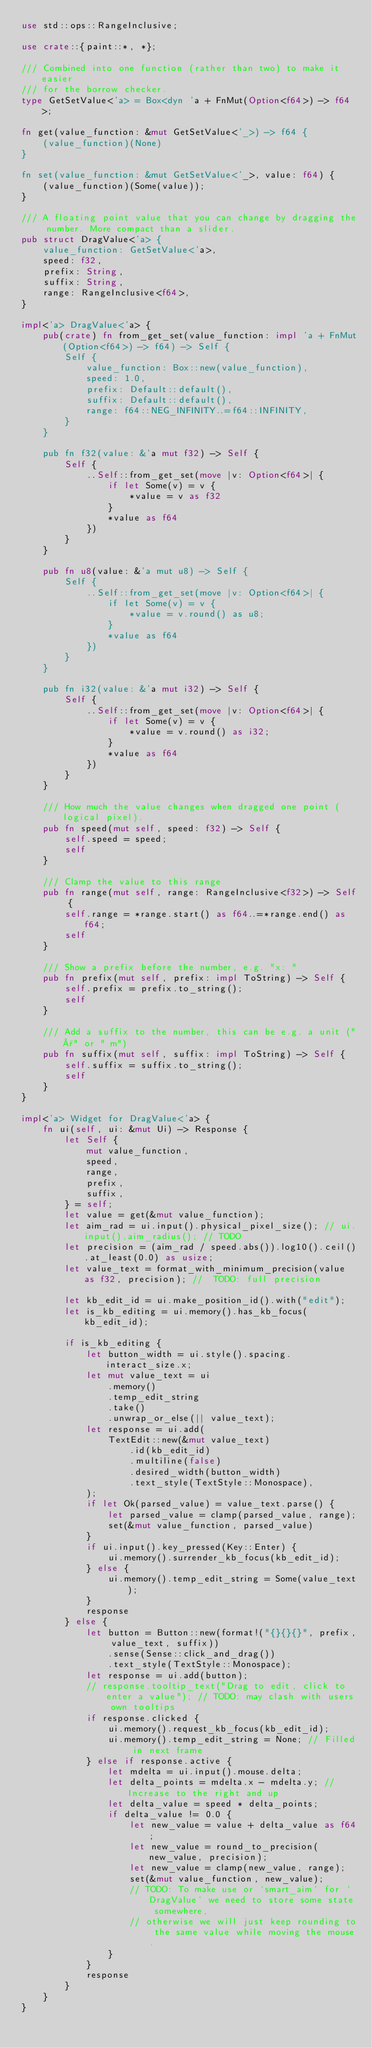<code> <loc_0><loc_0><loc_500><loc_500><_Rust_>use std::ops::RangeInclusive;

use crate::{paint::*, *};

/// Combined into one function (rather than two) to make it easier
/// for the borrow checker.
type GetSetValue<'a> = Box<dyn 'a + FnMut(Option<f64>) -> f64>;

fn get(value_function: &mut GetSetValue<'_>) -> f64 {
    (value_function)(None)
}

fn set(value_function: &mut GetSetValue<'_>, value: f64) {
    (value_function)(Some(value));
}

/// A floating point value that you can change by dragging the number. More compact than a slider.
pub struct DragValue<'a> {
    value_function: GetSetValue<'a>,
    speed: f32,
    prefix: String,
    suffix: String,
    range: RangeInclusive<f64>,
}

impl<'a> DragValue<'a> {
    pub(crate) fn from_get_set(value_function: impl 'a + FnMut(Option<f64>) -> f64) -> Self {
        Self {
            value_function: Box::new(value_function),
            speed: 1.0,
            prefix: Default::default(),
            suffix: Default::default(),
            range: f64::NEG_INFINITY..=f64::INFINITY,
        }
    }

    pub fn f32(value: &'a mut f32) -> Self {
        Self {
            ..Self::from_get_set(move |v: Option<f64>| {
                if let Some(v) = v {
                    *value = v as f32
                }
                *value as f64
            })
        }
    }

    pub fn u8(value: &'a mut u8) -> Self {
        Self {
            ..Self::from_get_set(move |v: Option<f64>| {
                if let Some(v) = v {
                    *value = v.round() as u8;
                }
                *value as f64
            })
        }
    }

    pub fn i32(value: &'a mut i32) -> Self {
        Self {
            ..Self::from_get_set(move |v: Option<f64>| {
                if let Some(v) = v {
                    *value = v.round() as i32;
                }
                *value as f64
            })
        }
    }

    /// How much the value changes when dragged one point (logical pixel).
    pub fn speed(mut self, speed: f32) -> Self {
        self.speed = speed;
        self
    }

    /// Clamp the value to this range
    pub fn range(mut self, range: RangeInclusive<f32>) -> Self {
        self.range = *range.start() as f64..=*range.end() as f64;
        self
    }

    /// Show a prefix before the number, e.g. "x: "
    pub fn prefix(mut self, prefix: impl ToString) -> Self {
        self.prefix = prefix.to_string();
        self
    }

    /// Add a suffix to the number, this can be e.g. a unit ("°" or " m")
    pub fn suffix(mut self, suffix: impl ToString) -> Self {
        self.suffix = suffix.to_string();
        self
    }
}

impl<'a> Widget for DragValue<'a> {
    fn ui(self, ui: &mut Ui) -> Response {
        let Self {
            mut value_function,
            speed,
            range,
            prefix,
            suffix,
        } = self;
        let value = get(&mut value_function);
        let aim_rad = ui.input().physical_pixel_size(); // ui.input().aim_radius(); // TODO
        let precision = (aim_rad / speed.abs()).log10().ceil().at_least(0.0) as usize;
        let value_text = format_with_minimum_precision(value as f32, precision); //  TODO: full precision

        let kb_edit_id = ui.make_position_id().with("edit");
        let is_kb_editing = ui.memory().has_kb_focus(kb_edit_id);

        if is_kb_editing {
            let button_width = ui.style().spacing.interact_size.x;
            let mut value_text = ui
                .memory()
                .temp_edit_string
                .take()
                .unwrap_or_else(|| value_text);
            let response = ui.add(
                TextEdit::new(&mut value_text)
                    .id(kb_edit_id)
                    .multiline(false)
                    .desired_width(button_width)
                    .text_style(TextStyle::Monospace),
            );
            if let Ok(parsed_value) = value_text.parse() {
                let parsed_value = clamp(parsed_value, range);
                set(&mut value_function, parsed_value)
            }
            if ui.input().key_pressed(Key::Enter) {
                ui.memory().surrender_kb_focus(kb_edit_id);
            } else {
                ui.memory().temp_edit_string = Some(value_text);
            }
            response
        } else {
            let button = Button::new(format!("{}{}{}", prefix, value_text, suffix))
                .sense(Sense::click_and_drag())
                .text_style(TextStyle::Monospace);
            let response = ui.add(button);
            // response.tooltip_text("Drag to edit, click to enter a value"); // TODO: may clash with users own tooltips
            if response.clicked {
                ui.memory().request_kb_focus(kb_edit_id);
                ui.memory().temp_edit_string = None; // Filled in next frame
            } else if response.active {
                let mdelta = ui.input().mouse.delta;
                let delta_points = mdelta.x - mdelta.y; // Increase to the right and up
                let delta_value = speed * delta_points;
                if delta_value != 0.0 {
                    let new_value = value + delta_value as f64;
                    let new_value = round_to_precision(new_value, precision);
                    let new_value = clamp(new_value, range);
                    set(&mut value_function, new_value);
                    // TODO: To make use or `smart_aim` for `DragValue` we need to store some state somewhere,
                    // otherwise we will just keep rounding to the same value while moving the mouse.
                }
            }
            response
        }
    }
}
</code> 